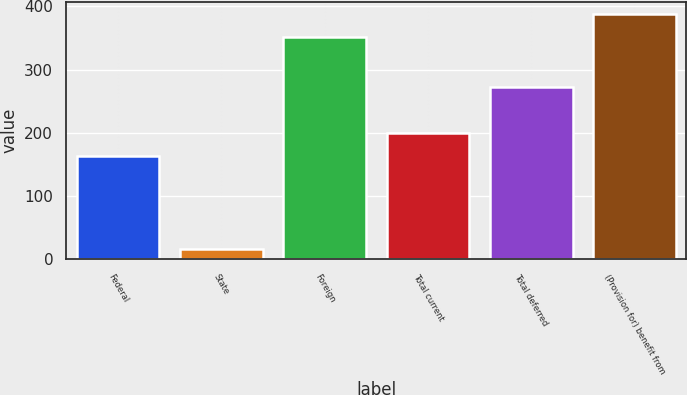Convert chart. <chart><loc_0><loc_0><loc_500><loc_500><bar_chart><fcel>Federal<fcel>State<fcel>Foreign<fcel>Total current<fcel>Total deferred<fcel>(Provision for) benefit from<nl><fcel>164<fcel>17<fcel>352<fcel>199.4<fcel>273<fcel>387.4<nl></chart> 